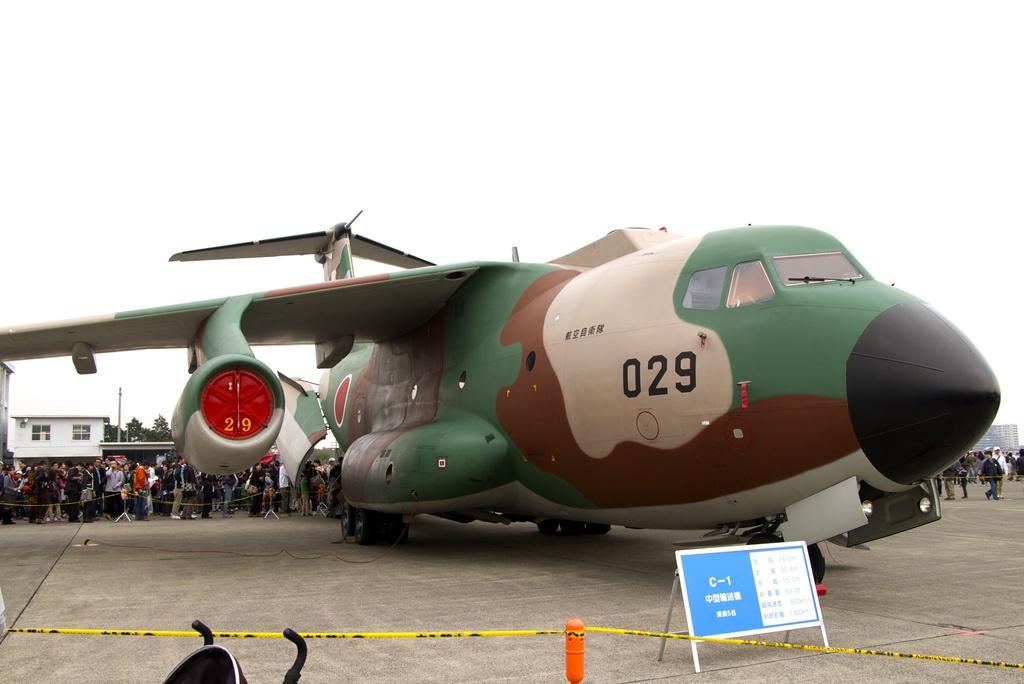<image>
Describe the image concisely. a camo plane number 029 is being borded 